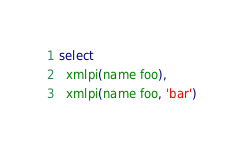<code> <loc_0><loc_0><loc_500><loc_500><_SQL_>select
  xmlpi(name foo),
  xmlpi(name foo, 'bar')
</code> 